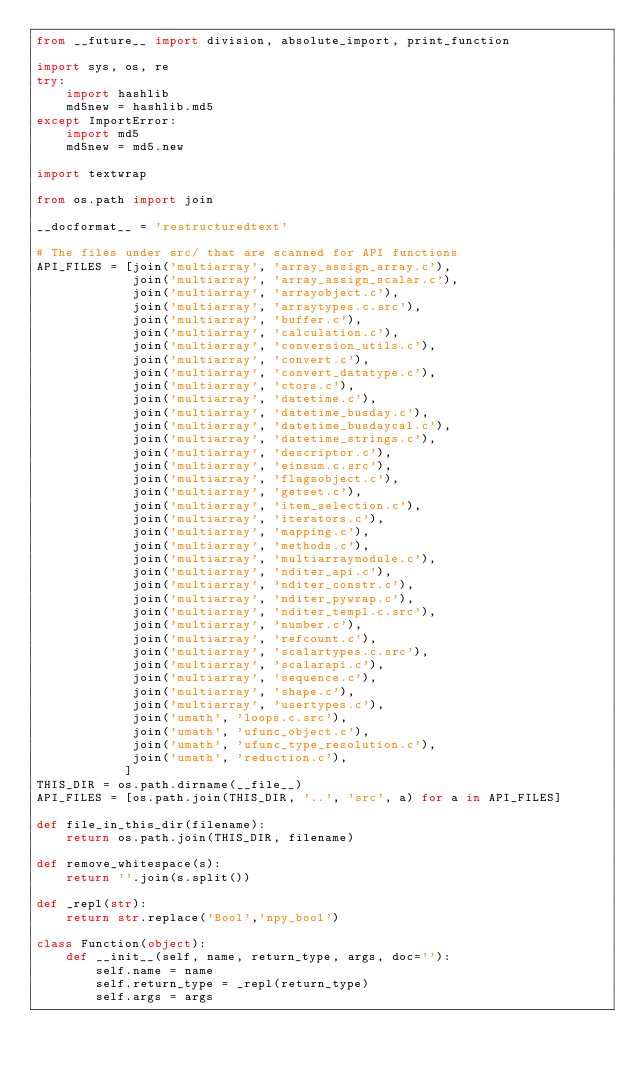Convert code to text. <code><loc_0><loc_0><loc_500><loc_500><_Python_>from __future__ import division, absolute_import, print_function

import sys, os, re
try:
    import hashlib
    md5new = hashlib.md5
except ImportError:
    import md5
    md5new = md5.new

import textwrap

from os.path import join

__docformat__ = 'restructuredtext'

# The files under src/ that are scanned for API functions
API_FILES = [join('multiarray', 'array_assign_array.c'),
             join('multiarray', 'array_assign_scalar.c'),
             join('multiarray', 'arrayobject.c'),
             join('multiarray', 'arraytypes.c.src'),
             join('multiarray', 'buffer.c'),
             join('multiarray', 'calculation.c'),
             join('multiarray', 'conversion_utils.c'),
             join('multiarray', 'convert.c'),
             join('multiarray', 'convert_datatype.c'),
             join('multiarray', 'ctors.c'),
             join('multiarray', 'datetime.c'),
             join('multiarray', 'datetime_busday.c'),
             join('multiarray', 'datetime_busdaycal.c'),
             join('multiarray', 'datetime_strings.c'),
             join('multiarray', 'descriptor.c'),
             join('multiarray', 'einsum.c.src'),
             join('multiarray', 'flagsobject.c'),
             join('multiarray', 'getset.c'),
             join('multiarray', 'item_selection.c'),
             join('multiarray', 'iterators.c'),
             join('multiarray', 'mapping.c'),
             join('multiarray', 'methods.c'),
             join('multiarray', 'multiarraymodule.c'),
             join('multiarray', 'nditer_api.c'),
             join('multiarray', 'nditer_constr.c'),
             join('multiarray', 'nditer_pywrap.c'),
             join('multiarray', 'nditer_templ.c.src'),
             join('multiarray', 'number.c'),
             join('multiarray', 'refcount.c'),
             join('multiarray', 'scalartypes.c.src'),
             join('multiarray', 'scalarapi.c'),
             join('multiarray', 'sequence.c'),
             join('multiarray', 'shape.c'),
             join('multiarray', 'usertypes.c'),
             join('umath', 'loops.c.src'),
             join('umath', 'ufunc_object.c'),
             join('umath', 'ufunc_type_resolution.c'),
             join('umath', 'reduction.c'),
            ]
THIS_DIR = os.path.dirname(__file__)
API_FILES = [os.path.join(THIS_DIR, '..', 'src', a) for a in API_FILES]

def file_in_this_dir(filename):
    return os.path.join(THIS_DIR, filename)

def remove_whitespace(s):
    return ''.join(s.split())

def _repl(str):
    return str.replace('Bool','npy_bool')

class Function(object):
    def __init__(self, name, return_type, args, doc=''):
        self.name = name
        self.return_type = _repl(return_type)
        self.args = args</code> 